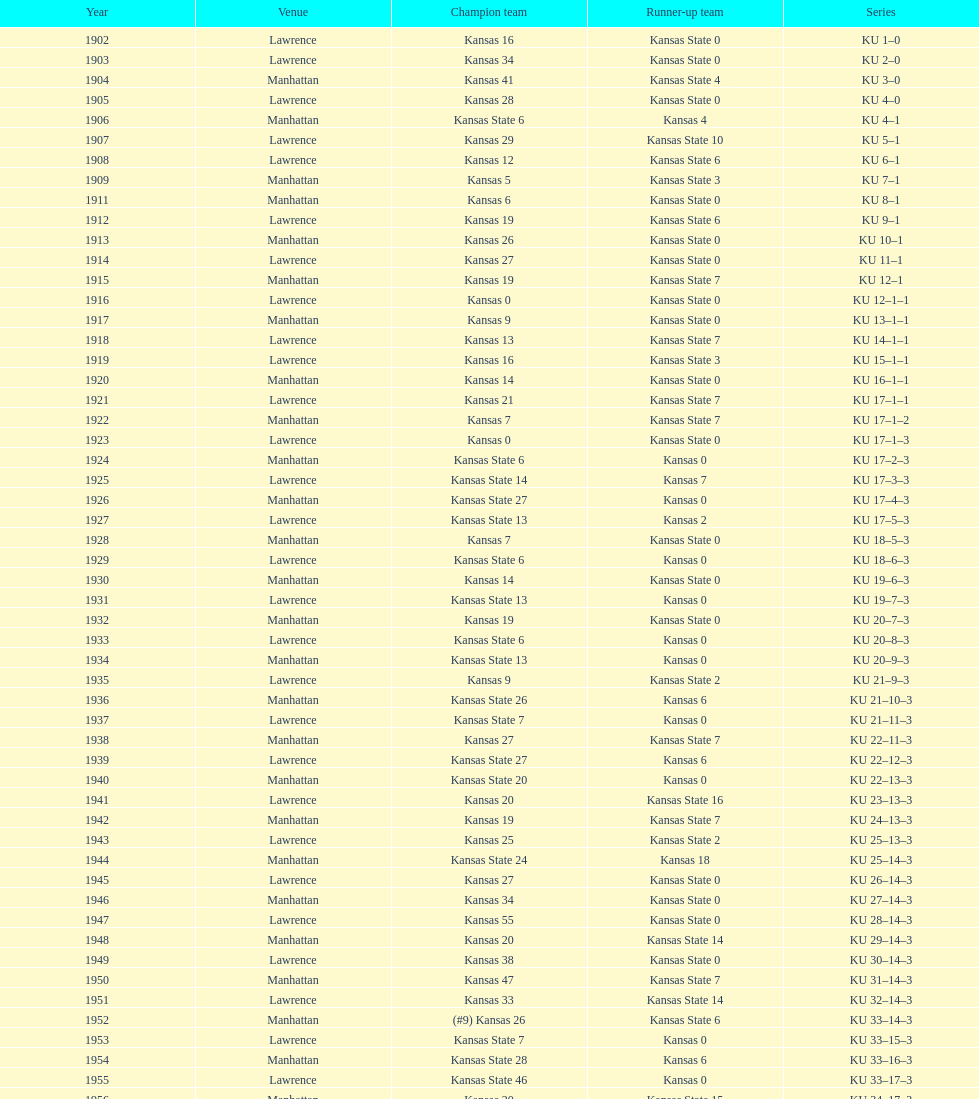In which game did kansas state first secure a win with a double-digit margin? 1926. 